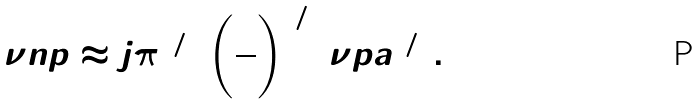<formula> <loc_0><loc_0><loc_500><loc_500>\nu n p \approx j \pi ^ { 1 / 5 } \left ( \frac { 2 } { 3 } \right ) ^ { 6 / 5 } \nu p a ^ { 6 / 5 } .</formula> 